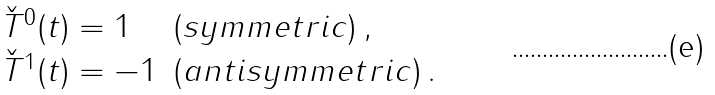<formula> <loc_0><loc_0><loc_500><loc_500>\begin{array} { l l } \check { T } ^ { 0 } ( t ) = 1 & ( s y m m e t r i c ) \, , \\ \check { T } ^ { 1 } ( t ) = - 1 & ( a n t i s y m m e t r i c ) \, . \end{array}</formula> 